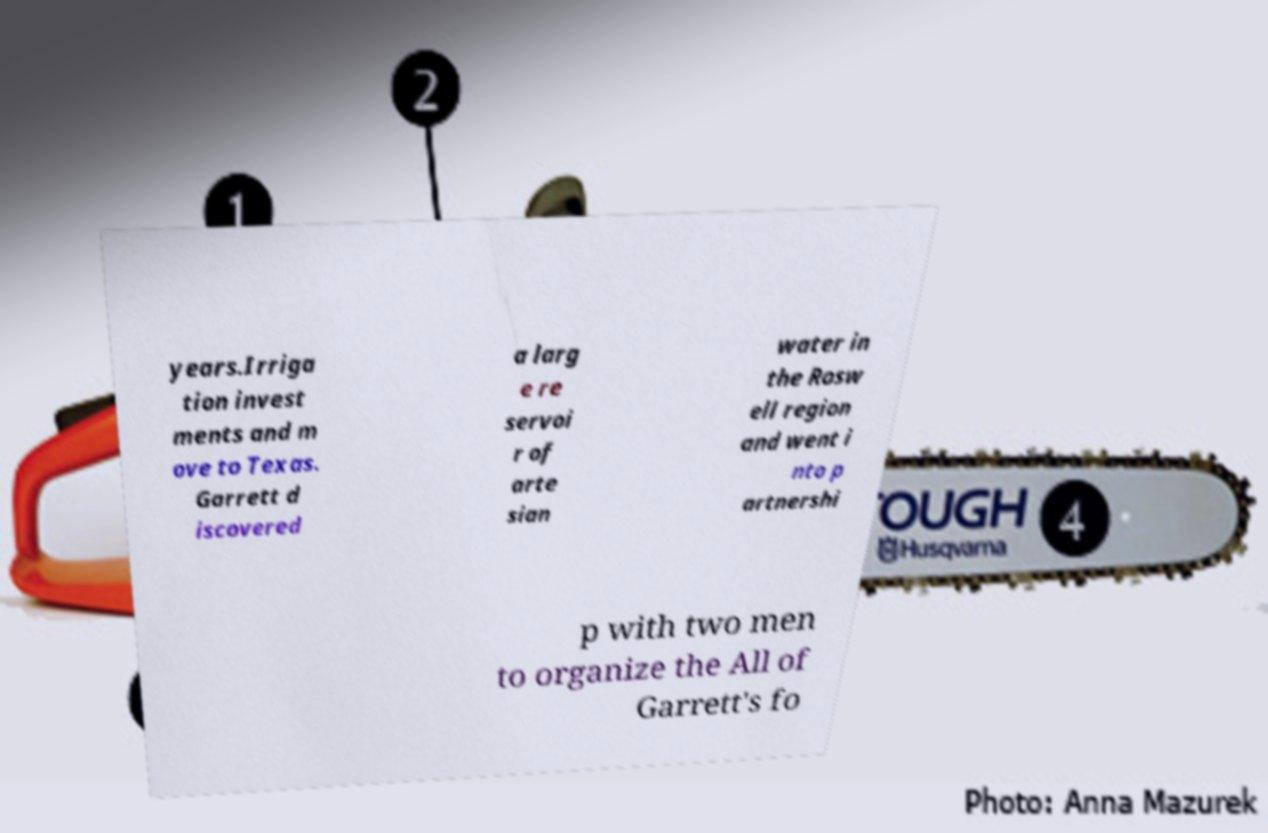There's text embedded in this image that I need extracted. Can you transcribe it verbatim? years.Irriga tion invest ments and m ove to Texas. Garrett d iscovered a larg e re servoi r of arte sian water in the Rosw ell region and went i nto p artnershi p with two men to organize the All of Garrett's fo 